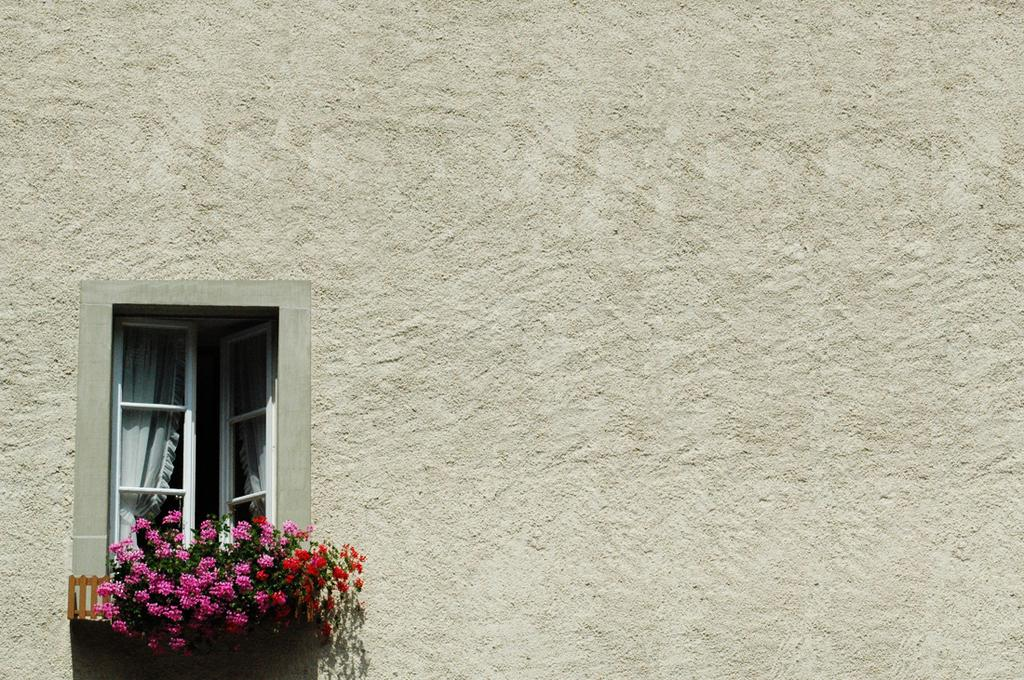What type of doors are present in the image? There are window doors in the image. What type of window treatment is visible in the image? There are curtains in the image. What can be seen near the window in the image? There are plants with flowers at the window. What type of steel is used to make the plants in the image? There is no steel present in the image, as the plants are made of organic materials. How does the stomach of the plant appear in the image? There is no reference to a plant's stomach in the image, as plants do not have stomachs. 